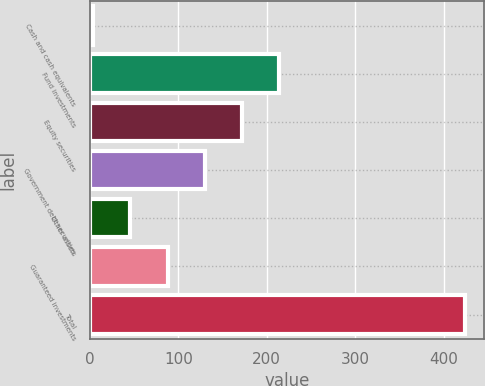<chart> <loc_0><loc_0><loc_500><loc_500><bar_chart><fcel>Cash and cash equivalents<fcel>Fund investments<fcel>Equity securities<fcel>Government debt securities<fcel>Other assets<fcel>Guaranteed investments<fcel>Total<nl><fcel>3.9<fcel>214<fcel>171.98<fcel>129.96<fcel>45.92<fcel>87.94<fcel>424.1<nl></chart> 